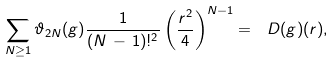Convert formula to latex. <formula><loc_0><loc_0><loc_500><loc_500>\sum _ { N \geq 1 } \vartheta _ { 2 N } ( g ) \frac { 1 } { ( N \, - \, 1 ) ! ^ { 2 } } \left ( \frac { r ^ { 2 } } { 4 } \right ) ^ { N - 1 } = \ D ( g ) ( r ) ,</formula> 